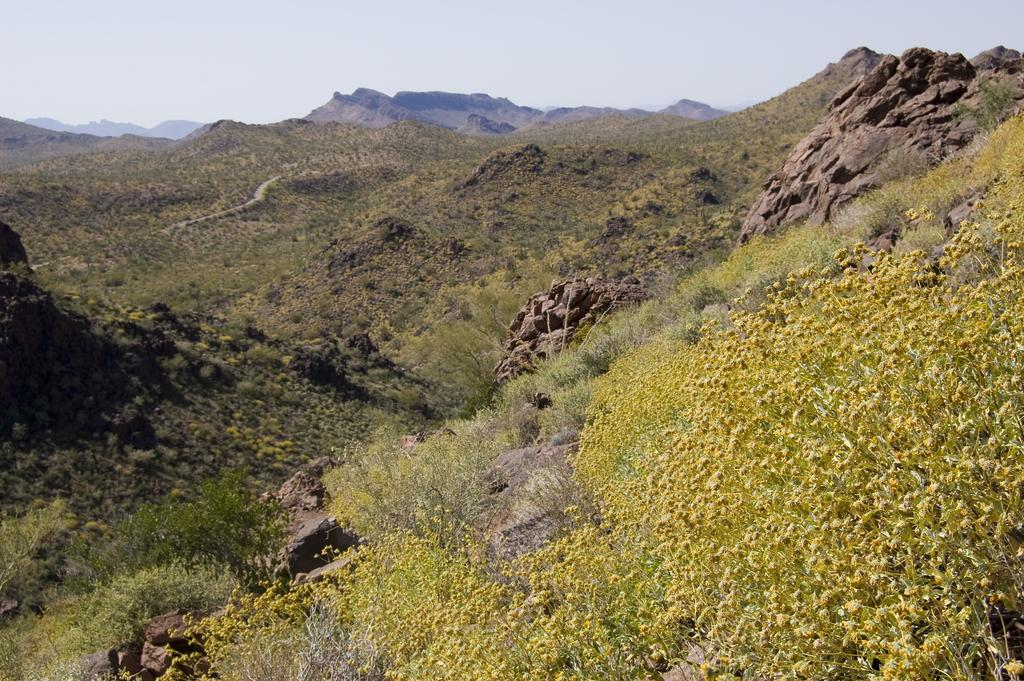What can be found at the bottom of the image? There are plants, rocks, mountains, and flowers at the bottom of the image. What type of vegetation is present at the bottom of the image? There are plants and flowers at the bottom of the image. What geological features can be seen at the bottom of the image? There are rocks and mountains at the bottom of the image. What is visible in the background of the image? There are mountains in the background of the image. What part of the natural environment is visible at the top of the image? The sky is visible at the top of the image. Can you tell me how many pumpkins are on the rocks in the image? There are no pumpkins present in the image; it features plants, rocks, mountains, flowers, and the sky. Is there a squirrel climbing the mountain in the background of the image? There is no squirrel visible in the image; it only shows plants, rocks, mountains, flowers, and the sky. 